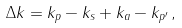<formula> <loc_0><loc_0><loc_500><loc_500>\Delta k = k _ { p } - k _ { s } + k _ { a } - k _ { p ^ { \prime } } \, ,</formula> 